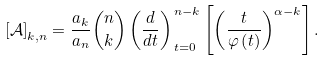<formula> <loc_0><loc_0><loc_500><loc_500>\left [ \mathcal { A } \right ] _ { k , n } = \frac { a _ { k } } { a _ { n } } \binom { n } { k } \left ( \frac { d } { d t } \right ) _ { \, t = 0 } ^ { \, n - k } \left [ \left ( \frac { t } { \varphi \left ( t \right ) } \right ) ^ { \alpha - k } \right ] .</formula> 